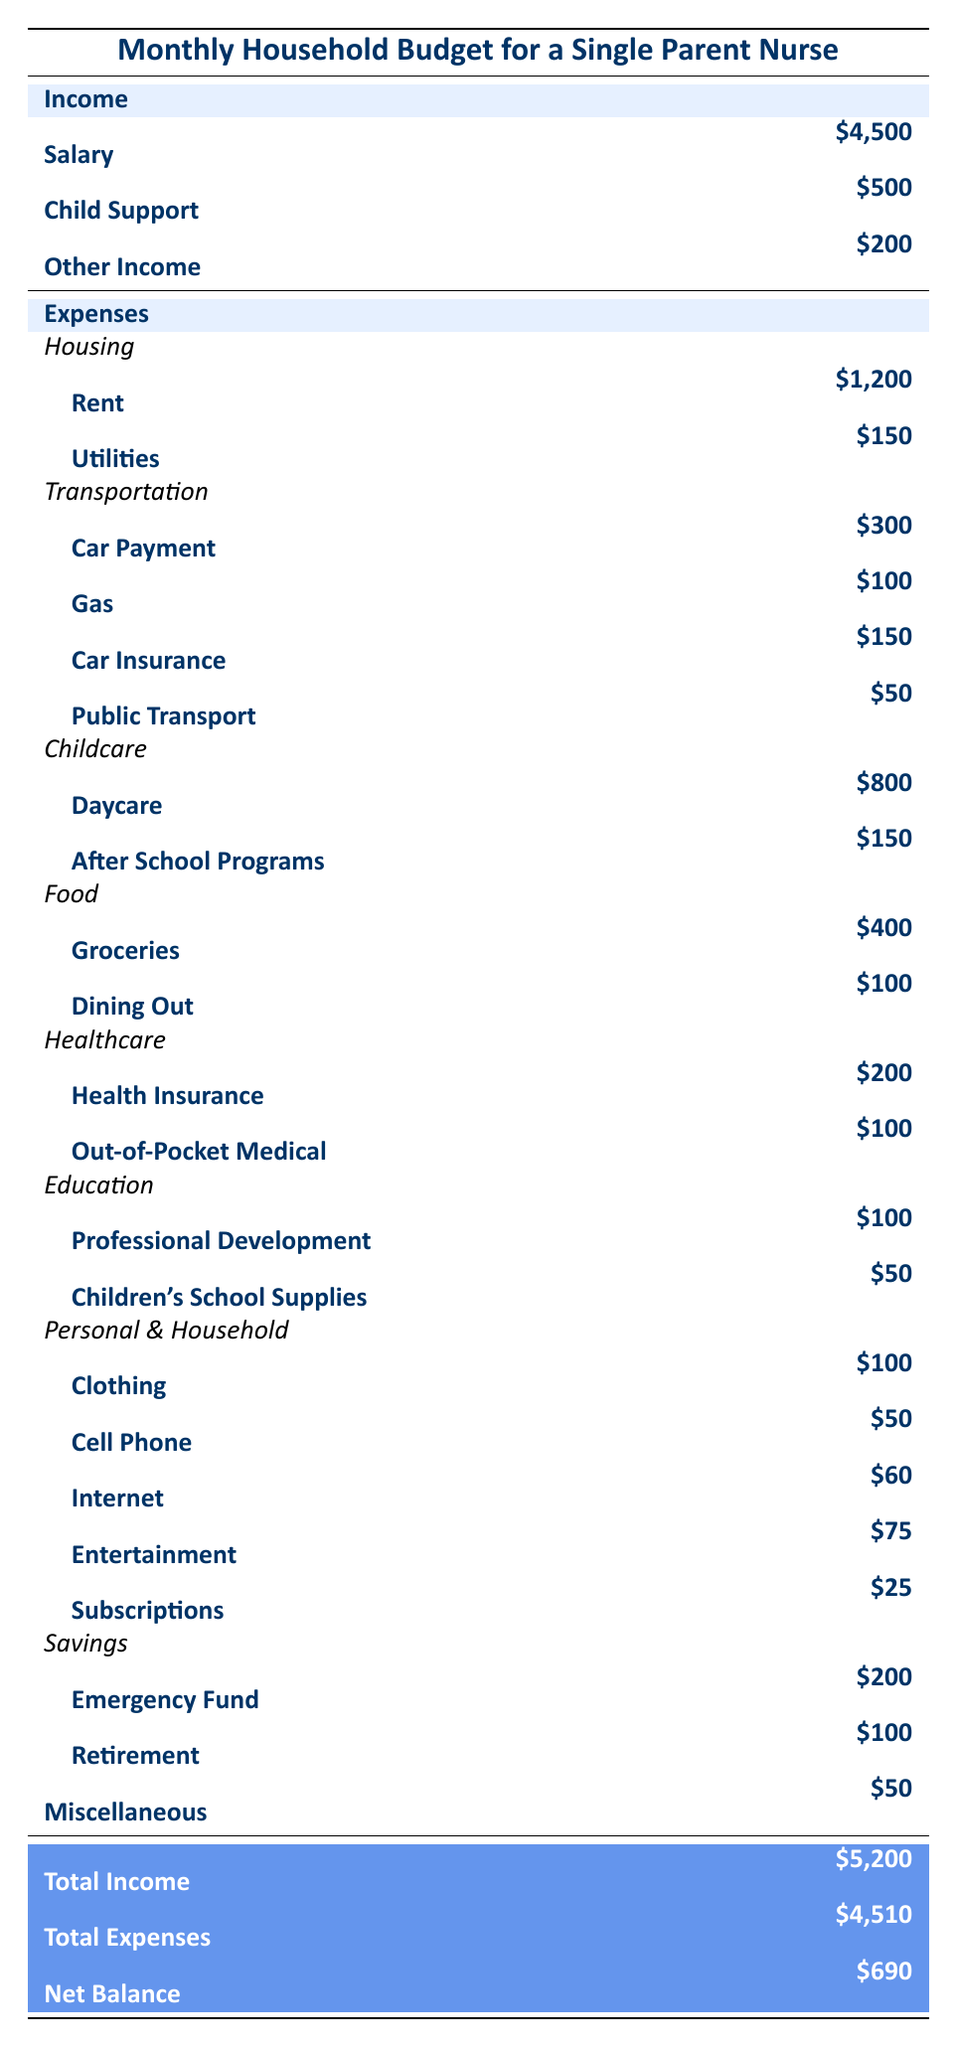What is the total income for the month? The total income is the sum of salary, child support, and other income. Adding these values: 4500 + 500 + 200 equals 5200.
Answer: 5200 How much is spent on childcare each month? The total childcare expenses are the sum of daycare and after school programs. Adding these two values: 800 + 150 equals 950.
Answer: 950 Is the net balance positive? The net balance is calculated by subtracting total expenses from total income. The total expenses are 4510, so 5200 - 4510 equals 690, which is positive.
Answer: Yes What are the total monthly housing expenses? The total housing expenses include rent and utilities. Adding these expenses yields 1200 + 150 equals 1350.
Answer: 1350 How much is allocated for personal and household expenses? The personal and household expenses include clothing, cell phone, internet, entertainment, and subscriptions. Adding these values gives 100 + 50 + 60 + 75 + 25 equals 310.
Answer: 310 What is the average expense for food each month? The food expenses include groceries and dining out. To find the average, first sum the expenses (400 + 100 = 500) and then divide by the number of categories (2), resulting in an average of 250.
Answer: 250 Is the health insurance expense higher than the daycare expense? The health insurance expense is 200, while daycare is 800. Since 200 is less than 800, the statement is false.
Answer: No How much is saved in total for emergency fund and retirement? The total savings include emergency fund and retirement contributions. Adding these values gives 200 + 100 equals 300.
Answer: 300 What percentage of the total income is spent on transportation? The total transportation expenses add up to 300 + 100 + 150 + 50, which equals 600. To find the percentage, divide the expenses by total income (600 / 5200) and multiply by 100, giving approximately 11.54%.
Answer: 11.54% 